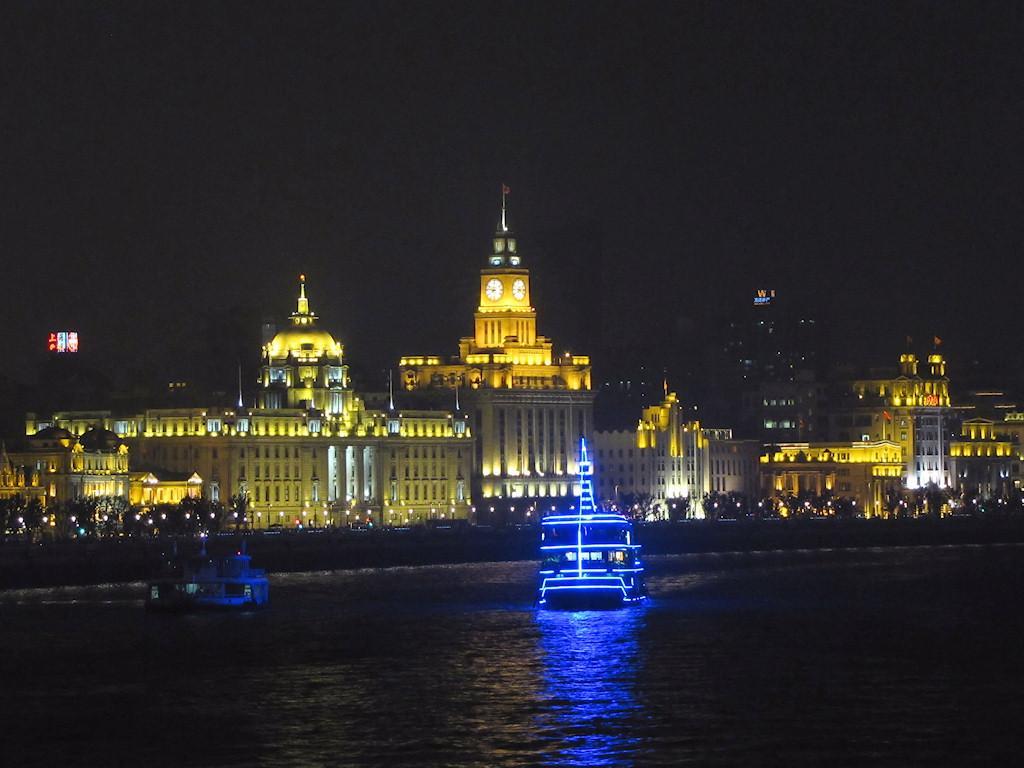In one or two sentences, can you explain what this image depicts? In this image I can see the water, two boats in the surface of the water, blue colored light to the boat, few lights, few trees, few poles, few buildings and a clock to the building. In the background I can see the dark sky. 